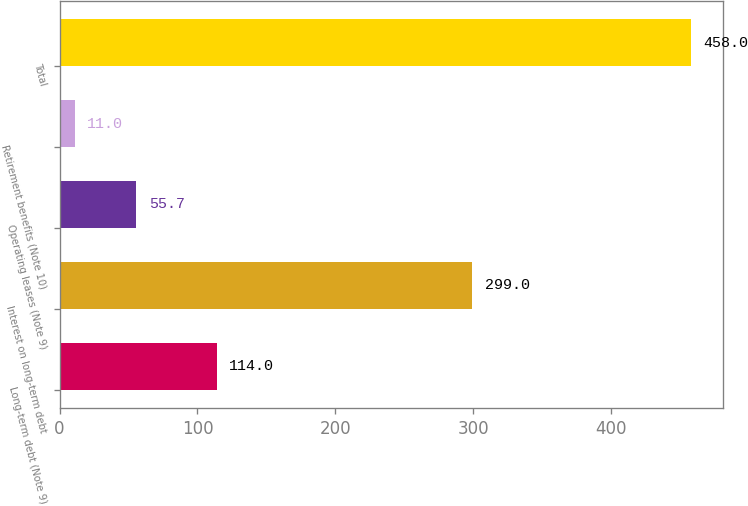<chart> <loc_0><loc_0><loc_500><loc_500><bar_chart><fcel>Long-term debt (Note 9)<fcel>Interest on long-term debt<fcel>Operating leases (Note 9)<fcel>Retirement benefits (Note 10)<fcel>Total<nl><fcel>114<fcel>299<fcel>55.7<fcel>11<fcel>458<nl></chart> 